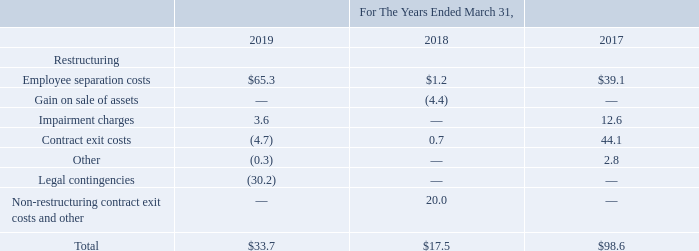Note 4. Special Charges and Other, Net
The following table summarizes activity included in the "special charges and other, net" caption on the Company's consolidated statements of income (in millions):
The Company continuously evaluates its existing operations in an attempt to identify and realize cost savings opportunities and operational efficiencies. This same approach is applied to businesses that are acquired by the Company and often the operating models of acquired companies are not as efficient as the Company's operating model which enables the Company to realize significant savings and efficiencies. As a result, following an acquisition, the Company will from time to time incur restructuring expenses; however, the Company is often not able to estimate the timing or amount of such costs in advance of the period in which they occur. The primary reason for this is that the Company regularly reviews and evaluates each position, contract and expense against the Company's strategic objectives, long-term operating targets and other operational priorities. Decisions related to restructuring activities are made on a "rolling basis" during the course of the integration of an acquisition whereby department managers, executives and other leaders work together to evaluate each of these expenses and make recommendations. As a result of this approach, at the time of an acquisition, the Company is not able to estimate the future amount of expected employee separation or exit costs that it will incur in connection with its restructuring activities.
The Company's restructuring expenses during the fiscal year ended March 31, 2019 were related to the Company's most recent business acquisitions, and resulted from workforce, property and other operating expense rationalizations as well as combining product roadmaps and manufacturing operations. These expenses were for employee separation costs and intangible asset impairment charges. The impairment charges in the fiscal year ended March 31, 2019 were primarily recognized as a result of writing off intangible assets purchased from Microsemi prior to the close of the acquisition and other intangible assets that were impaired as a result of changes in the combined product roadmaps after the acquisition that affected the use and life of the assets. Additional costs will be incurred in the future as additional synergies or operational efficiencies are identified in connection with the Microsemi transaction and other previous acquisitions. The Company is not able to estimate the amount of such future expenses at this time.
During fiscal 2018, the Company incurred expenses including non-restructuring contract exit costs of $19.5 million for fees associated with transitioning from the public utility provider in Oregon to a lower cost direct access provider. The fee is paid monthly and will depend on the amount of actual energy consumed by the Company's wafer fabrication facility in Oregon over the next five years. In connection with the transition to a direct access provider, the Company signed a ten-year supply agreement to purchase monthly amounts of energy that are less than the current average usage and priced on a per mega watt hour published index rate in effect at those future dates. Also during fiscal 2018, the Company incurred $1.2 million of employee separation costs in connection with the acquisition of Atmel.
The Company's restructuring expenses during fiscal 2017 were related to the Company's acquisitions of Atmel and Micrel, and resulted from workforce, property and other operating expense rationalizations as well as combining product roadmaps and manufacturing operations. These expenses were for employee separation costs, contract exit costs, other operating expenses and intangible asset impairment losses. The impairment charges in fiscal 2017 were recognized as a result of changes in the combined product roadmaps after the acquisition of Atmel that affected the use and life of these assets. At March 31, 2017, these activities were substantially complete.
All of the Company's restructuring activities occurred in its semiconductor products segment. The Company incurred $115.2 million in costs since the start of fiscal 2016 in connection with employee separation activities, of which $65.3 million, $1.2 million and $39.1 million was incurred during the fiscal years ended March 31, 2019, 2018 and 2017, respectively. The Company could incur future expenses as additional synergies or operational efficiencies are identified. The Company is not able to estimate future expenses, if any, to be incurred in employee separation costs. The Company has incurred $40.8 million in costs in connection with contract exit activities since the start of fiscal 2016 which includes $4.7 million of income incurred for the year ended March 31, 2019 and $0.7 million and $44.1 million of costs incurred for the years ended March 31, 2018 and 2017, respectively. The amounts recognized during the fiscal year ended March 31, 2019 were primarily related to vacated lease liabilities. While the Company expects to incur further acquisition-related contract exit expenses, it is not able to estimate the amount at this time.
In the three months ended June 30, 2017, the Company completed the sale of an asset it acquired as part of its acquisition of Micrel for proceeds of $10.0 million and the gain of $4.4 million is included in the gain on sale of assets in the above table.
How much was the cost incurred by the company since the start of fiscal 2016 in connection with employee separation activities? $115.2 million. Which years does the table provide information for activity included in the "special charges and other, net" caption on the Company's consolidated statements of income? 2019, 2018, 2017. How much were Employee separation costs in 2019?
Answer scale should be: million. 65.3. What was the change in Employee separation costs between 2017 and 2018?
Answer scale should be: million. 1.2-39.1
Answer: -37.9. What was the change in Impairment charges between 2017 and 2019?
Answer scale should be: million. 3.6-12.6
Answer: -9. What was the change in the total between 2018 and 2019?
Answer scale should be: percent. (33.7-17.5)/17.5
Answer: 92.57. 